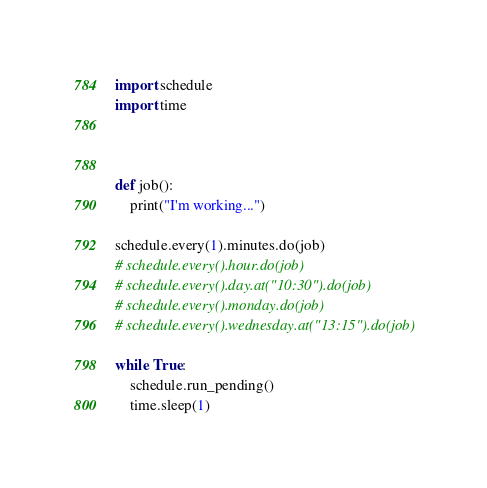<code> <loc_0><loc_0><loc_500><loc_500><_Python_>import schedule
import time



def job():
    print("I'm working...")

schedule.every(1).minutes.do(job)
# schedule.every().hour.do(job)
# schedule.every().day.at("10:30").do(job)
# schedule.every().monday.do(job)
# schedule.every().wednesday.at("13:15").do(job)

while True:
    schedule.run_pending()
    time.sleep(1)</code> 